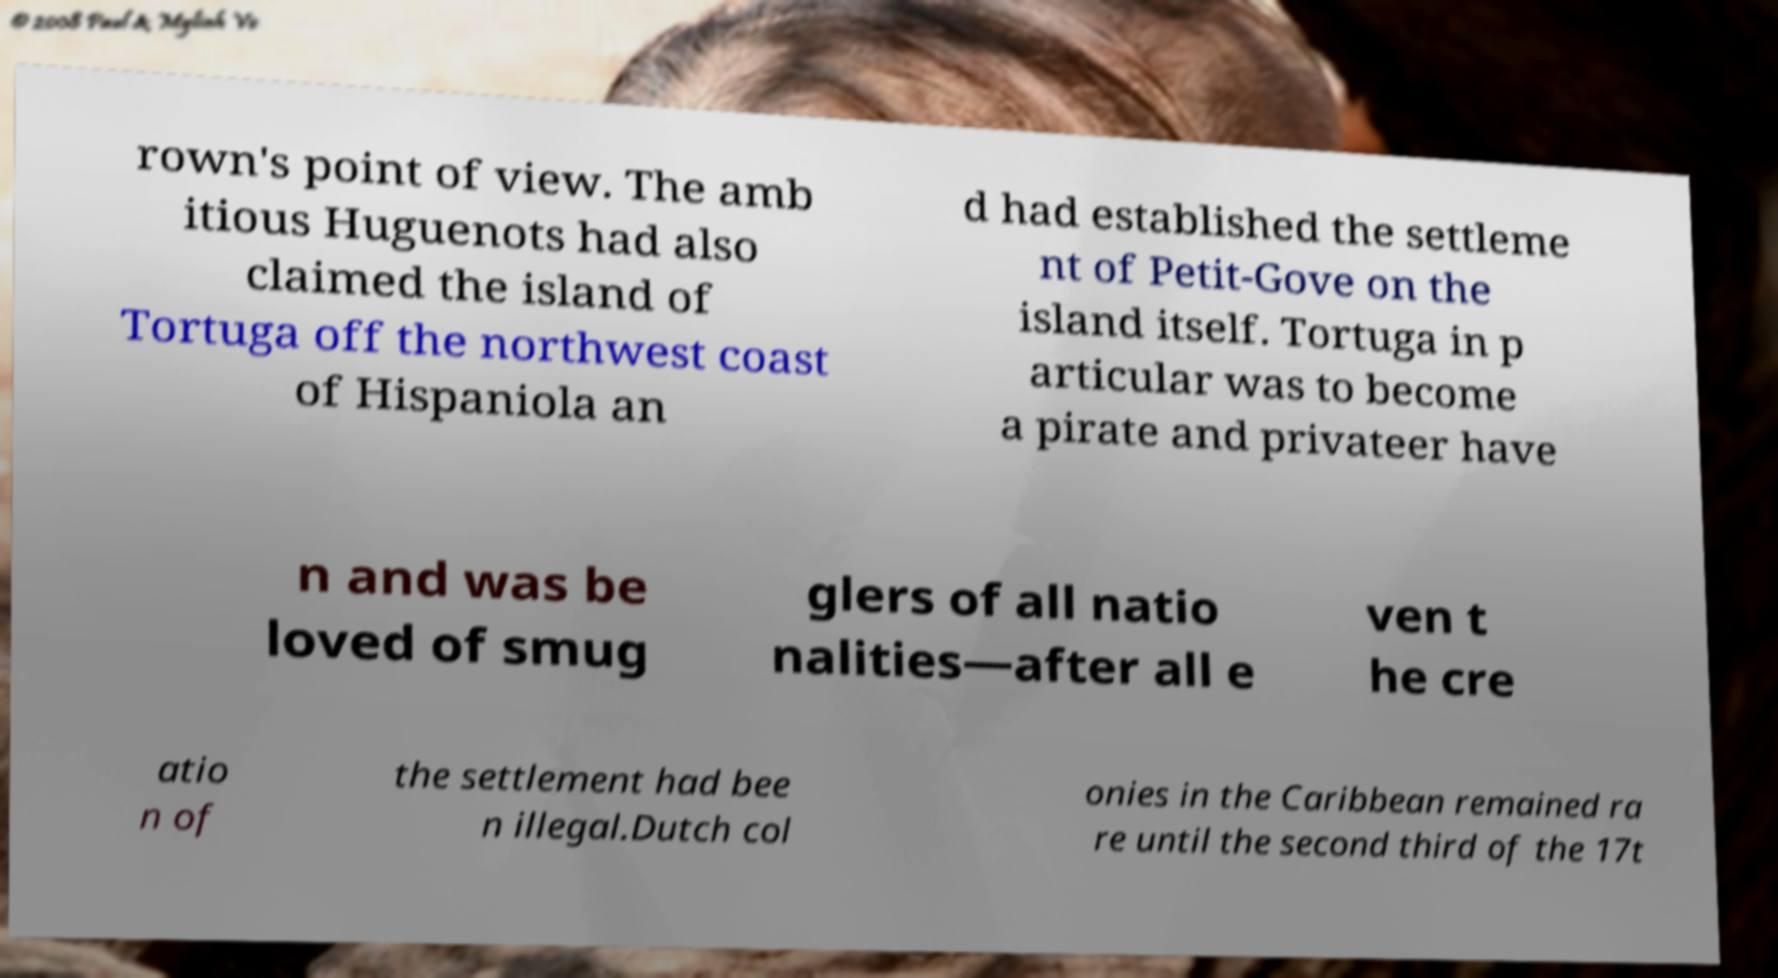Can you read and provide the text displayed in the image?This photo seems to have some interesting text. Can you extract and type it out for me? rown's point of view. The amb itious Huguenots had also claimed the island of Tortuga off the northwest coast of Hispaniola an d had established the settleme nt of Petit-Gove on the island itself. Tortuga in p articular was to become a pirate and privateer have n and was be loved of smug glers of all natio nalities—after all e ven t he cre atio n of the settlement had bee n illegal.Dutch col onies in the Caribbean remained ra re until the second third of the 17t 